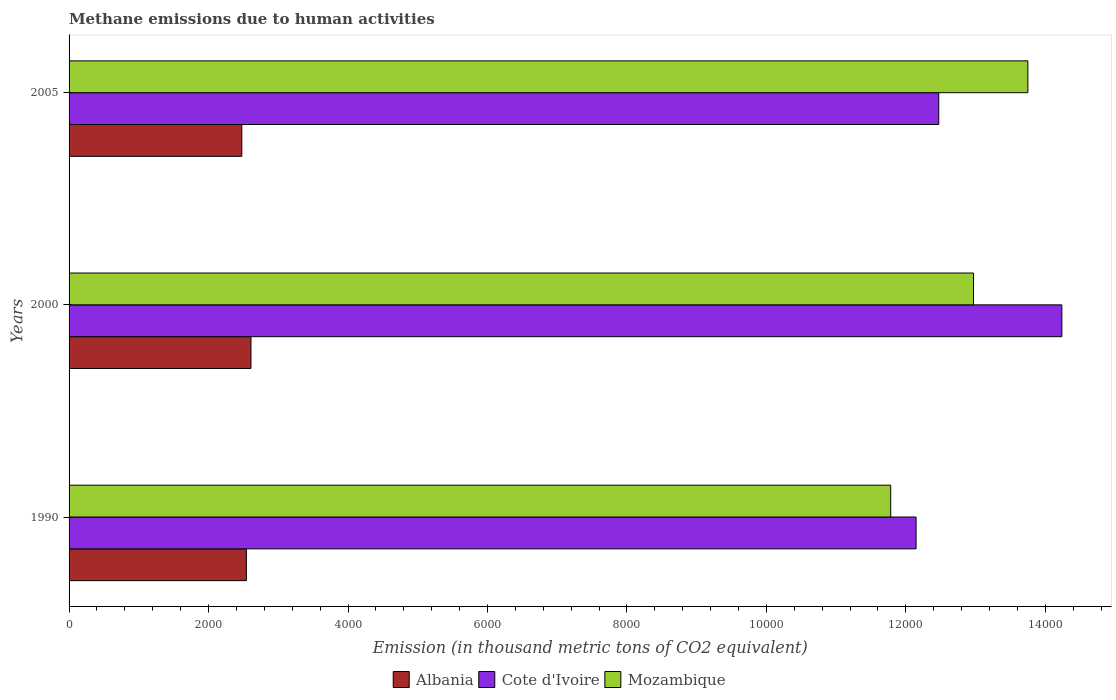How many groups of bars are there?
Your answer should be very brief. 3. How many bars are there on the 1st tick from the top?
Offer a terse response. 3. What is the label of the 2nd group of bars from the top?
Give a very brief answer. 2000. What is the amount of methane emitted in Cote d'Ivoire in 2000?
Provide a succinct answer. 1.42e+04. Across all years, what is the maximum amount of methane emitted in Mozambique?
Give a very brief answer. 1.37e+04. Across all years, what is the minimum amount of methane emitted in Cote d'Ivoire?
Your answer should be very brief. 1.21e+04. In which year was the amount of methane emitted in Albania minimum?
Make the answer very short. 2005. What is the total amount of methane emitted in Albania in the graph?
Give a very brief answer. 7628.3. What is the difference between the amount of methane emitted in Mozambique in 2000 and that in 2005?
Give a very brief answer. -779.2. What is the difference between the amount of methane emitted in Mozambique in 2005 and the amount of methane emitted in Albania in 2000?
Make the answer very short. 1.11e+04. What is the average amount of methane emitted in Albania per year?
Your answer should be compact. 2542.77. In the year 2000, what is the difference between the amount of methane emitted in Mozambique and amount of methane emitted in Cote d'Ivoire?
Offer a very short reply. -1266.5. In how many years, is the amount of methane emitted in Mozambique greater than 4400 thousand metric tons?
Give a very brief answer. 3. What is the ratio of the amount of methane emitted in Albania in 1990 to that in 2000?
Offer a terse response. 0.97. Is the amount of methane emitted in Albania in 1990 less than that in 2005?
Keep it short and to the point. No. Is the difference between the amount of methane emitted in Mozambique in 2000 and 2005 greater than the difference between the amount of methane emitted in Cote d'Ivoire in 2000 and 2005?
Offer a terse response. No. What is the difference between the highest and the second highest amount of methane emitted in Mozambique?
Ensure brevity in your answer.  779.2. What is the difference between the highest and the lowest amount of methane emitted in Cote d'Ivoire?
Make the answer very short. 2090.5. Is the sum of the amount of methane emitted in Cote d'Ivoire in 1990 and 2005 greater than the maximum amount of methane emitted in Mozambique across all years?
Offer a very short reply. Yes. What does the 1st bar from the top in 2000 represents?
Make the answer very short. Mozambique. What does the 2nd bar from the bottom in 1990 represents?
Your answer should be compact. Cote d'Ivoire. Is it the case that in every year, the sum of the amount of methane emitted in Albania and amount of methane emitted in Cote d'Ivoire is greater than the amount of methane emitted in Mozambique?
Your answer should be very brief. Yes. Are all the bars in the graph horizontal?
Your response must be concise. Yes. What is the difference between two consecutive major ticks on the X-axis?
Offer a very short reply. 2000. Does the graph contain grids?
Provide a short and direct response. No. What is the title of the graph?
Ensure brevity in your answer.  Methane emissions due to human activities. What is the label or title of the X-axis?
Your response must be concise. Emission (in thousand metric tons of CO2 equivalent). What is the label or title of the Y-axis?
Your answer should be very brief. Years. What is the Emission (in thousand metric tons of CO2 equivalent) of Albania in 1990?
Offer a terse response. 2542.8. What is the Emission (in thousand metric tons of CO2 equivalent) in Cote d'Ivoire in 1990?
Provide a short and direct response. 1.21e+04. What is the Emission (in thousand metric tons of CO2 equivalent) in Mozambique in 1990?
Give a very brief answer. 1.18e+04. What is the Emission (in thousand metric tons of CO2 equivalent) of Albania in 2000?
Your answer should be compact. 2608.4. What is the Emission (in thousand metric tons of CO2 equivalent) of Cote d'Ivoire in 2000?
Your response must be concise. 1.42e+04. What is the Emission (in thousand metric tons of CO2 equivalent) in Mozambique in 2000?
Ensure brevity in your answer.  1.30e+04. What is the Emission (in thousand metric tons of CO2 equivalent) of Albania in 2005?
Offer a terse response. 2477.1. What is the Emission (in thousand metric tons of CO2 equivalent) in Cote d'Ivoire in 2005?
Keep it short and to the point. 1.25e+04. What is the Emission (in thousand metric tons of CO2 equivalent) in Mozambique in 2005?
Ensure brevity in your answer.  1.37e+04. Across all years, what is the maximum Emission (in thousand metric tons of CO2 equivalent) of Albania?
Offer a terse response. 2608.4. Across all years, what is the maximum Emission (in thousand metric tons of CO2 equivalent) in Cote d'Ivoire?
Your answer should be compact. 1.42e+04. Across all years, what is the maximum Emission (in thousand metric tons of CO2 equivalent) of Mozambique?
Give a very brief answer. 1.37e+04. Across all years, what is the minimum Emission (in thousand metric tons of CO2 equivalent) of Albania?
Your response must be concise. 2477.1. Across all years, what is the minimum Emission (in thousand metric tons of CO2 equivalent) in Cote d'Ivoire?
Make the answer very short. 1.21e+04. Across all years, what is the minimum Emission (in thousand metric tons of CO2 equivalent) in Mozambique?
Provide a short and direct response. 1.18e+04. What is the total Emission (in thousand metric tons of CO2 equivalent) in Albania in the graph?
Provide a succinct answer. 7628.3. What is the total Emission (in thousand metric tons of CO2 equivalent) in Cote d'Ivoire in the graph?
Provide a succinct answer. 3.89e+04. What is the total Emission (in thousand metric tons of CO2 equivalent) in Mozambique in the graph?
Keep it short and to the point. 3.85e+04. What is the difference between the Emission (in thousand metric tons of CO2 equivalent) of Albania in 1990 and that in 2000?
Provide a short and direct response. -65.6. What is the difference between the Emission (in thousand metric tons of CO2 equivalent) in Cote d'Ivoire in 1990 and that in 2000?
Ensure brevity in your answer.  -2090.5. What is the difference between the Emission (in thousand metric tons of CO2 equivalent) of Mozambique in 1990 and that in 2000?
Give a very brief answer. -1187.6. What is the difference between the Emission (in thousand metric tons of CO2 equivalent) in Albania in 1990 and that in 2005?
Give a very brief answer. 65.7. What is the difference between the Emission (in thousand metric tons of CO2 equivalent) in Cote d'Ivoire in 1990 and that in 2005?
Your response must be concise. -325.2. What is the difference between the Emission (in thousand metric tons of CO2 equivalent) of Mozambique in 1990 and that in 2005?
Your answer should be compact. -1966.8. What is the difference between the Emission (in thousand metric tons of CO2 equivalent) of Albania in 2000 and that in 2005?
Offer a very short reply. 131.3. What is the difference between the Emission (in thousand metric tons of CO2 equivalent) of Cote d'Ivoire in 2000 and that in 2005?
Your answer should be compact. 1765.3. What is the difference between the Emission (in thousand metric tons of CO2 equivalent) in Mozambique in 2000 and that in 2005?
Keep it short and to the point. -779.2. What is the difference between the Emission (in thousand metric tons of CO2 equivalent) of Albania in 1990 and the Emission (in thousand metric tons of CO2 equivalent) of Cote d'Ivoire in 2000?
Provide a succinct answer. -1.17e+04. What is the difference between the Emission (in thousand metric tons of CO2 equivalent) in Albania in 1990 and the Emission (in thousand metric tons of CO2 equivalent) in Mozambique in 2000?
Provide a short and direct response. -1.04e+04. What is the difference between the Emission (in thousand metric tons of CO2 equivalent) of Cote d'Ivoire in 1990 and the Emission (in thousand metric tons of CO2 equivalent) of Mozambique in 2000?
Provide a short and direct response. -824. What is the difference between the Emission (in thousand metric tons of CO2 equivalent) in Albania in 1990 and the Emission (in thousand metric tons of CO2 equivalent) in Cote d'Ivoire in 2005?
Offer a terse response. -9928.7. What is the difference between the Emission (in thousand metric tons of CO2 equivalent) in Albania in 1990 and the Emission (in thousand metric tons of CO2 equivalent) in Mozambique in 2005?
Ensure brevity in your answer.  -1.12e+04. What is the difference between the Emission (in thousand metric tons of CO2 equivalent) in Cote d'Ivoire in 1990 and the Emission (in thousand metric tons of CO2 equivalent) in Mozambique in 2005?
Your answer should be very brief. -1603.2. What is the difference between the Emission (in thousand metric tons of CO2 equivalent) in Albania in 2000 and the Emission (in thousand metric tons of CO2 equivalent) in Cote d'Ivoire in 2005?
Keep it short and to the point. -9863.1. What is the difference between the Emission (in thousand metric tons of CO2 equivalent) in Albania in 2000 and the Emission (in thousand metric tons of CO2 equivalent) in Mozambique in 2005?
Keep it short and to the point. -1.11e+04. What is the difference between the Emission (in thousand metric tons of CO2 equivalent) of Cote d'Ivoire in 2000 and the Emission (in thousand metric tons of CO2 equivalent) of Mozambique in 2005?
Offer a terse response. 487.3. What is the average Emission (in thousand metric tons of CO2 equivalent) in Albania per year?
Your answer should be compact. 2542.77. What is the average Emission (in thousand metric tons of CO2 equivalent) of Cote d'Ivoire per year?
Ensure brevity in your answer.  1.30e+04. What is the average Emission (in thousand metric tons of CO2 equivalent) in Mozambique per year?
Offer a very short reply. 1.28e+04. In the year 1990, what is the difference between the Emission (in thousand metric tons of CO2 equivalent) of Albania and Emission (in thousand metric tons of CO2 equivalent) of Cote d'Ivoire?
Offer a terse response. -9603.5. In the year 1990, what is the difference between the Emission (in thousand metric tons of CO2 equivalent) of Albania and Emission (in thousand metric tons of CO2 equivalent) of Mozambique?
Your answer should be very brief. -9239.9. In the year 1990, what is the difference between the Emission (in thousand metric tons of CO2 equivalent) of Cote d'Ivoire and Emission (in thousand metric tons of CO2 equivalent) of Mozambique?
Provide a succinct answer. 363.6. In the year 2000, what is the difference between the Emission (in thousand metric tons of CO2 equivalent) in Albania and Emission (in thousand metric tons of CO2 equivalent) in Cote d'Ivoire?
Your answer should be compact. -1.16e+04. In the year 2000, what is the difference between the Emission (in thousand metric tons of CO2 equivalent) of Albania and Emission (in thousand metric tons of CO2 equivalent) of Mozambique?
Ensure brevity in your answer.  -1.04e+04. In the year 2000, what is the difference between the Emission (in thousand metric tons of CO2 equivalent) of Cote d'Ivoire and Emission (in thousand metric tons of CO2 equivalent) of Mozambique?
Provide a short and direct response. 1266.5. In the year 2005, what is the difference between the Emission (in thousand metric tons of CO2 equivalent) in Albania and Emission (in thousand metric tons of CO2 equivalent) in Cote d'Ivoire?
Offer a very short reply. -9994.4. In the year 2005, what is the difference between the Emission (in thousand metric tons of CO2 equivalent) in Albania and Emission (in thousand metric tons of CO2 equivalent) in Mozambique?
Make the answer very short. -1.13e+04. In the year 2005, what is the difference between the Emission (in thousand metric tons of CO2 equivalent) of Cote d'Ivoire and Emission (in thousand metric tons of CO2 equivalent) of Mozambique?
Your response must be concise. -1278. What is the ratio of the Emission (in thousand metric tons of CO2 equivalent) of Albania in 1990 to that in 2000?
Make the answer very short. 0.97. What is the ratio of the Emission (in thousand metric tons of CO2 equivalent) of Cote d'Ivoire in 1990 to that in 2000?
Your answer should be compact. 0.85. What is the ratio of the Emission (in thousand metric tons of CO2 equivalent) in Mozambique in 1990 to that in 2000?
Offer a very short reply. 0.91. What is the ratio of the Emission (in thousand metric tons of CO2 equivalent) of Albania in 1990 to that in 2005?
Your answer should be compact. 1.03. What is the ratio of the Emission (in thousand metric tons of CO2 equivalent) in Cote d'Ivoire in 1990 to that in 2005?
Your answer should be very brief. 0.97. What is the ratio of the Emission (in thousand metric tons of CO2 equivalent) of Mozambique in 1990 to that in 2005?
Give a very brief answer. 0.86. What is the ratio of the Emission (in thousand metric tons of CO2 equivalent) of Albania in 2000 to that in 2005?
Ensure brevity in your answer.  1.05. What is the ratio of the Emission (in thousand metric tons of CO2 equivalent) of Cote d'Ivoire in 2000 to that in 2005?
Give a very brief answer. 1.14. What is the ratio of the Emission (in thousand metric tons of CO2 equivalent) of Mozambique in 2000 to that in 2005?
Offer a very short reply. 0.94. What is the difference between the highest and the second highest Emission (in thousand metric tons of CO2 equivalent) of Albania?
Ensure brevity in your answer.  65.6. What is the difference between the highest and the second highest Emission (in thousand metric tons of CO2 equivalent) of Cote d'Ivoire?
Make the answer very short. 1765.3. What is the difference between the highest and the second highest Emission (in thousand metric tons of CO2 equivalent) of Mozambique?
Provide a short and direct response. 779.2. What is the difference between the highest and the lowest Emission (in thousand metric tons of CO2 equivalent) in Albania?
Keep it short and to the point. 131.3. What is the difference between the highest and the lowest Emission (in thousand metric tons of CO2 equivalent) in Cote d'Ivoire?
Your response must be concise. 2090.5. What is the difference between the highest and the lowest Emission (in thousand metric tons of CO2 equivalent) in Mozambique?
Give a very brief answer. 1966.8. 